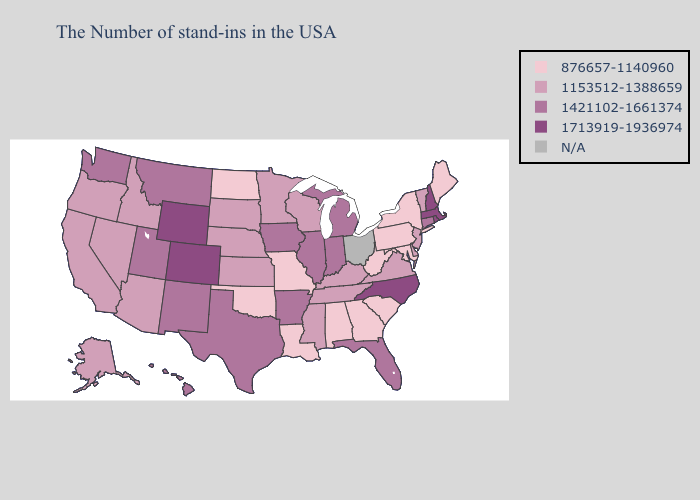Does Arizona have the lowest value in the USA?
Keep it brief. No. Does Wisconsin have the lowest value in the USA?
Keep it brief. No. Name the states that have a value in the range N/A?
Short answer required. Ohio. How many symbols are there in the legend?
Give a very brief answer. 5. Which states have the lowest value in the USA?
Give a very brief answer. Maine, New York, Maryland, Pennsylvania, South Carolina, West Virginia, Georgia, Alabama, Louisiana, Missouri, Oklahoma, North Dakota. What is the highest value in the USA?
Write a very short answer. 1713919-1936974. Among the states that border Idaho , does Oregon have the lowest value?
Answer briefly. Yes. Name the states that have a value in the range 1153512-1388659?
Quick response, please. Vermont, New Jersey, Delaware, Virginia, Kentucky, Tennessee, Wisconsin, Mississippi, Minnesota, Kansas, Nebraska, South Dakota, Arizona, Idaho, Nevada, California, Oregon, Alaska. Does the first symbol in the legend represent the smallest category?
Concise answer only. Yes. Which states have the lowest value in the Northeast?
Write a very short answer. Maine, New York, Pennsylvania. Does Montana have the highest value in the USA?
Be succinct. No. Name the states that have a value in the range 1153512-1388659?
Give a very brief answer. Vermont, New Jersey, Delaware, Virginia, Kentucky, Tennessee, Wisconsin, Mississippi, Minnesota, Kansas, Nebraska, South Dakota, Arizona, Idaho, Nevada, California, Oregon, Alaska. What is the lowest value in the USA?
Give a very brief answer. 876657-1140960. Name the states that have a value in the range 1713919-1936974?
Keep it brief. Massachusetts, Rhode Island, New Hampshire, North Carolina, Wyoming, Colorado. Which states have the lowest value in the USA?
Quick response, please. Maine, New York, Maryland, Pennsylvania, South Carolina, West Virginia, Georgia, Alabama, Louisiana, Missouri, Oklahoma, North Dakota. 